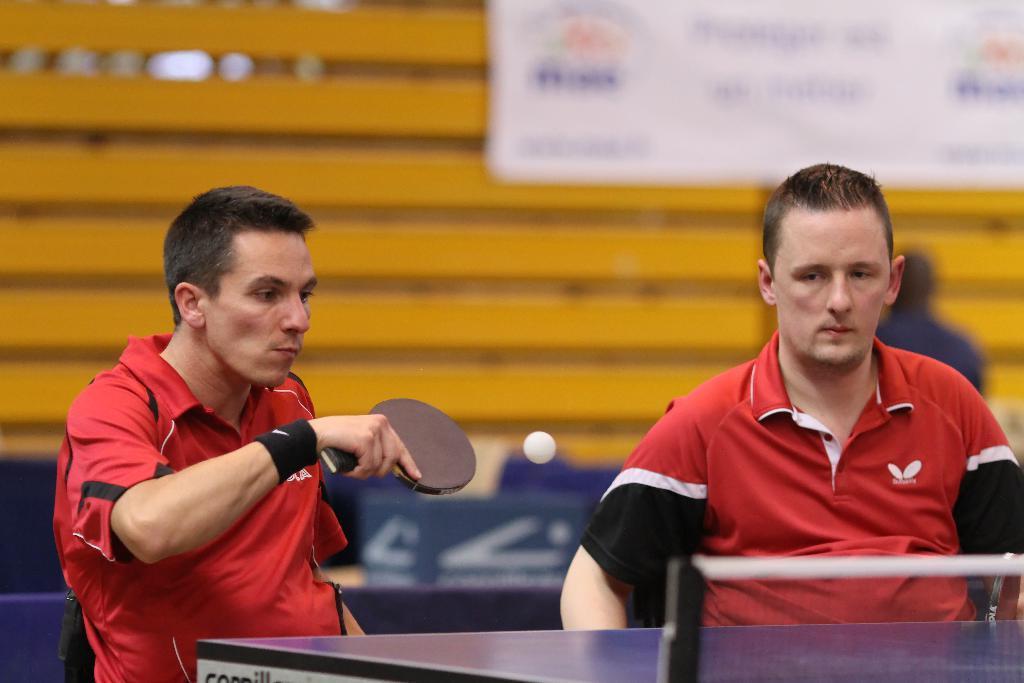Can you describe this image briefly? This image consists of two men sitting in the chairs and playing table tennis. In the background, we can see a poster and a wall like structure made of wood. 